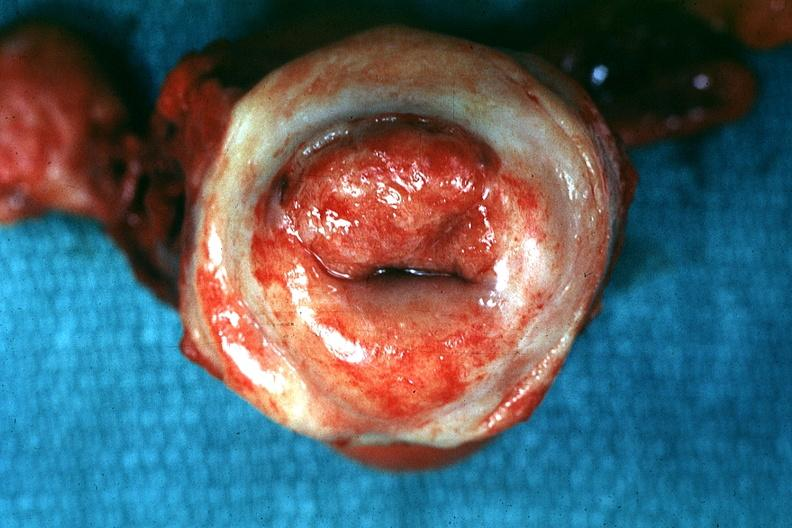s myoma lesion present?
Answer the question using a single word or phrase. No 